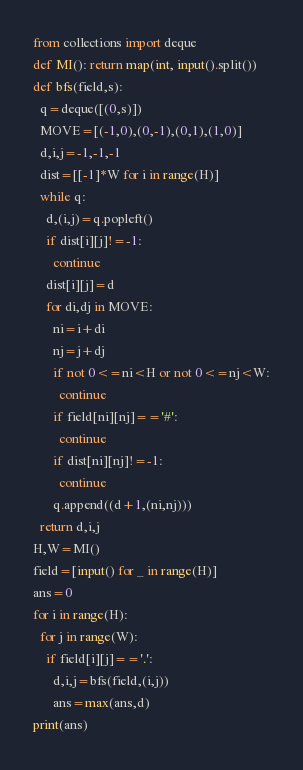<code> <loc_0><loc_0><loc_500><loc_500><_Python_>from collections import deque
def MI(): return map(int, input().split())
def bfs(field,s):
  q=deque([(0,s)])
  MOVE=[(-1,0),(0,-1),(0,1),(1,0)]
  d,i,j=-1,-1,-1
  dist=[[-1]*W for i in range(H)]  
  while q:
    d,(i,j)=q.popleft()
    if dist[i][j]!=-1:
      continue
    dist[i][j]=d
    for di,dj in MOVE:
      ni=i+di
      nj=j+dj
      if not 0<=ni<H or not 0<=nj<W:
        continue
      if field[ni][nj]=='#':
        continue
      if dist[ni][nj]!=-1:
        continue
      q.append((d+1,(ni,nj)))
  return d,i,j
H,W=MI()
field=[input() for _ in range(H)]
ans=0
for i in range(H):
  for j in range(W):
    if field[i][j]=='.':
      d,i,j=bfs(field,(i,j))      
      ans=max(ans,d)
print(ans)</code> 